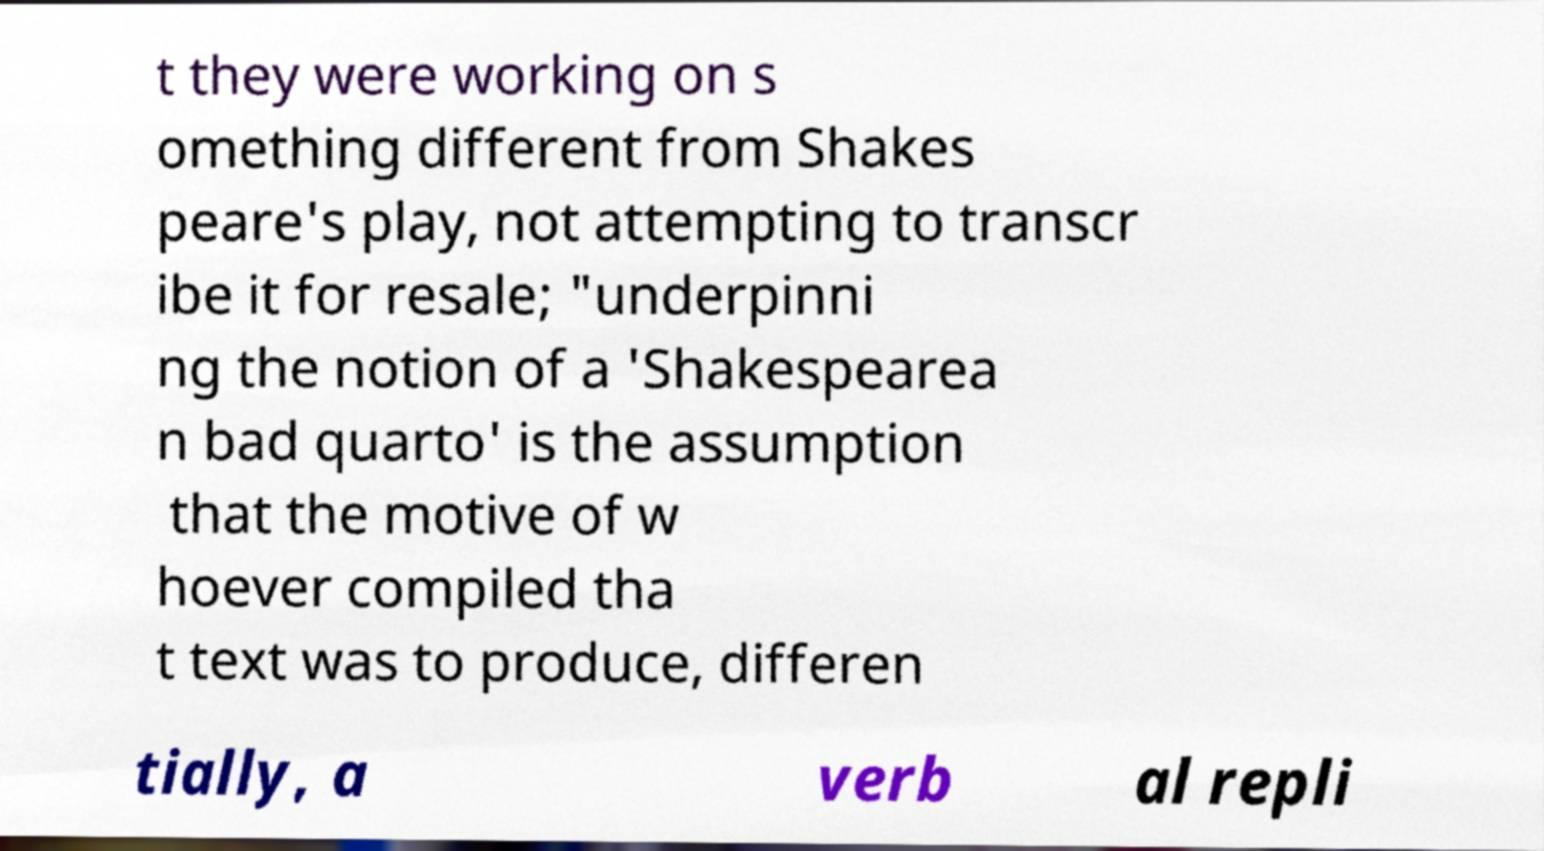What messages or text are displayed in this image? I need them in a readable, typed format. t they were working on s omething different from Shakes peare's play, not attempting to transcr ibe it for resale; "underpinni ng the notion of a 'Shakespearea n bad quarto' is the assumption that the motive of w hoever compiled tha t text was to produce, differen tially, a verb al repli 